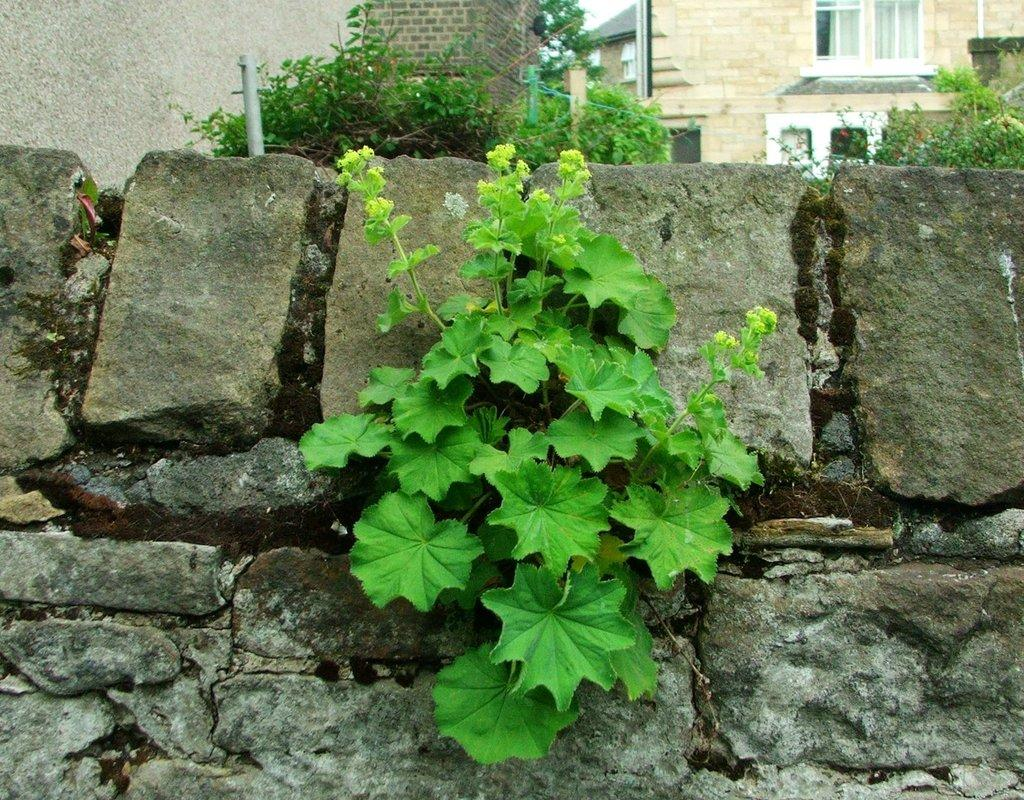What type of natural elements can be seen in the image? There are rocks and plants in the image. What type of man-made structures are visible in the image? There are buildings in the image. What architectural feature can be seen in the buildings? There are windows in the buildings. What type of oatmeal is being served in the image? There is no oatmeal present in the image. What type of produce can be seen growing near the buildings? There is no produce visible in the image; only rocks, plants, and buildings are present. 